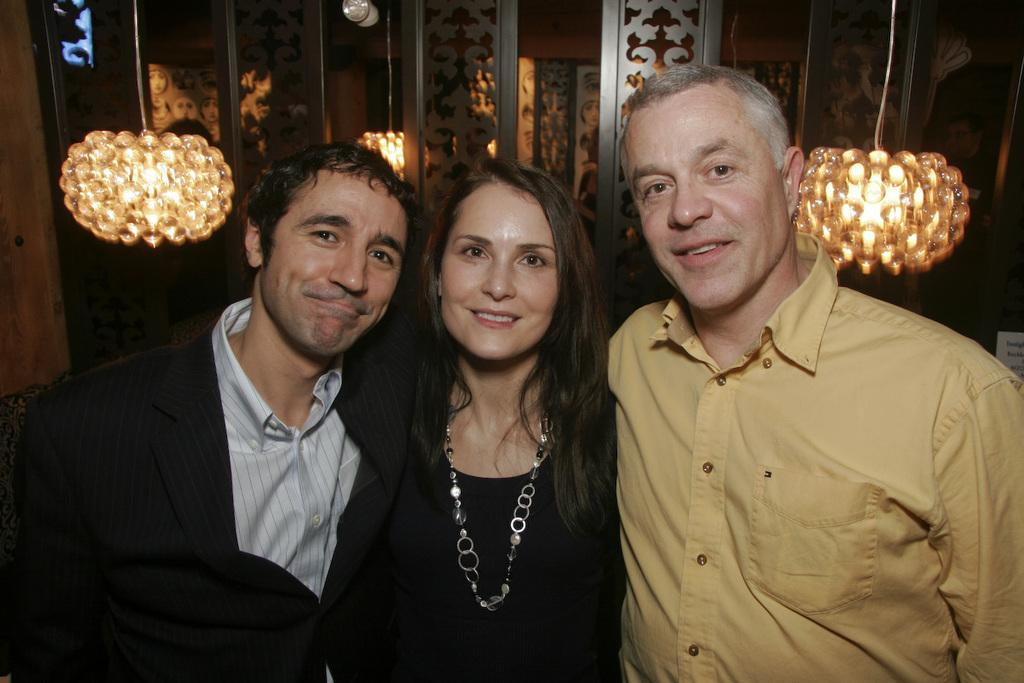How many people are in the image? There are three people in the image. What are the people doing in the image? The people are standing with smiles on their faces. What can be seen in the background of the image? There is a wall and lamps hanging in the background of the image. What type of sheet is being used for the chess game in the image? There is no chess game or sheet present in the image. What type of dinner is being served in the image? There is no dinner or food present in the image. 